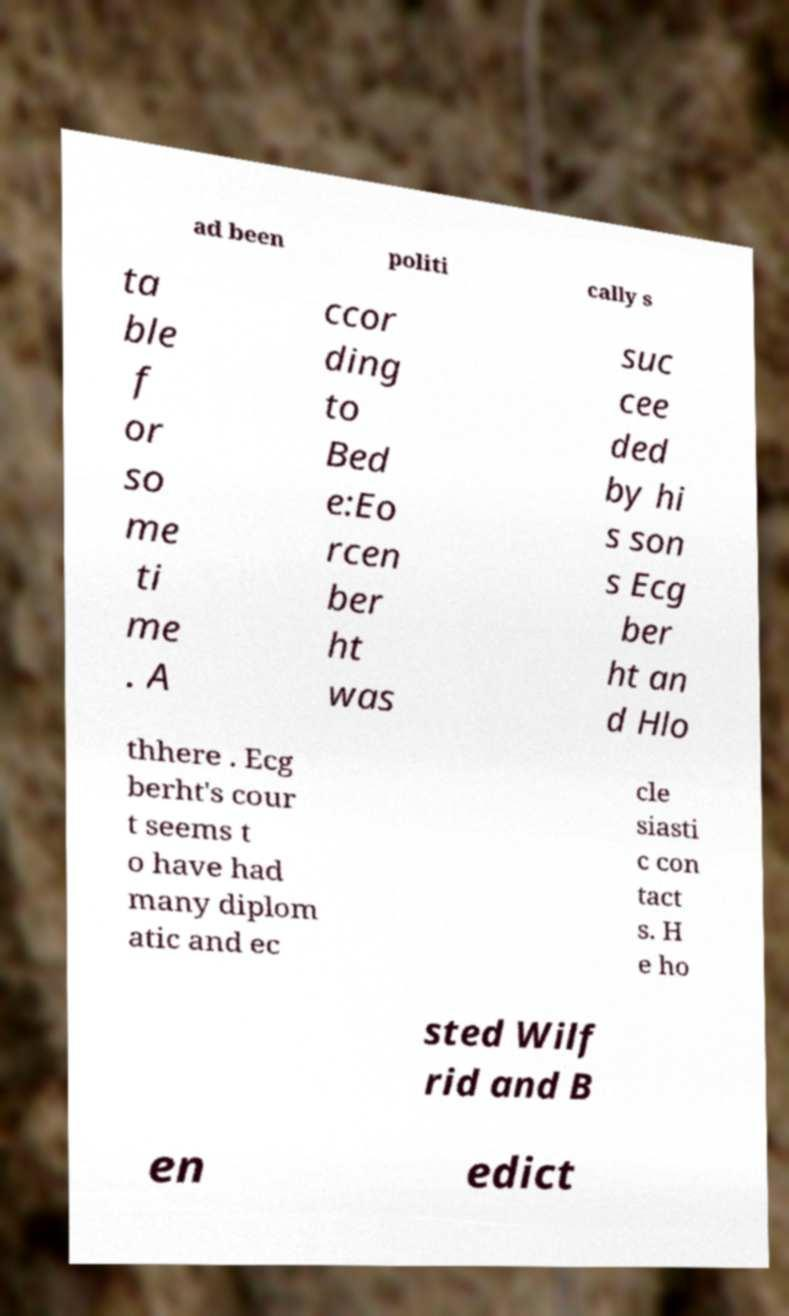Can you read and provide the text displayed in the image?This photo seems to have some interesting text. Can you extract and type it out for me? ad been politi cally s ta ble f or so me ti me . A ccor ding to Bed e:Eo rcen ber ht was suc cee ded by hi s son s Ecg ber ht an d Hlo thhere . Ecg berht's cour t seems t o have had many diplom atic and ec cle siasti c con tact s. H e ho sted Wilf rid and B en edict 